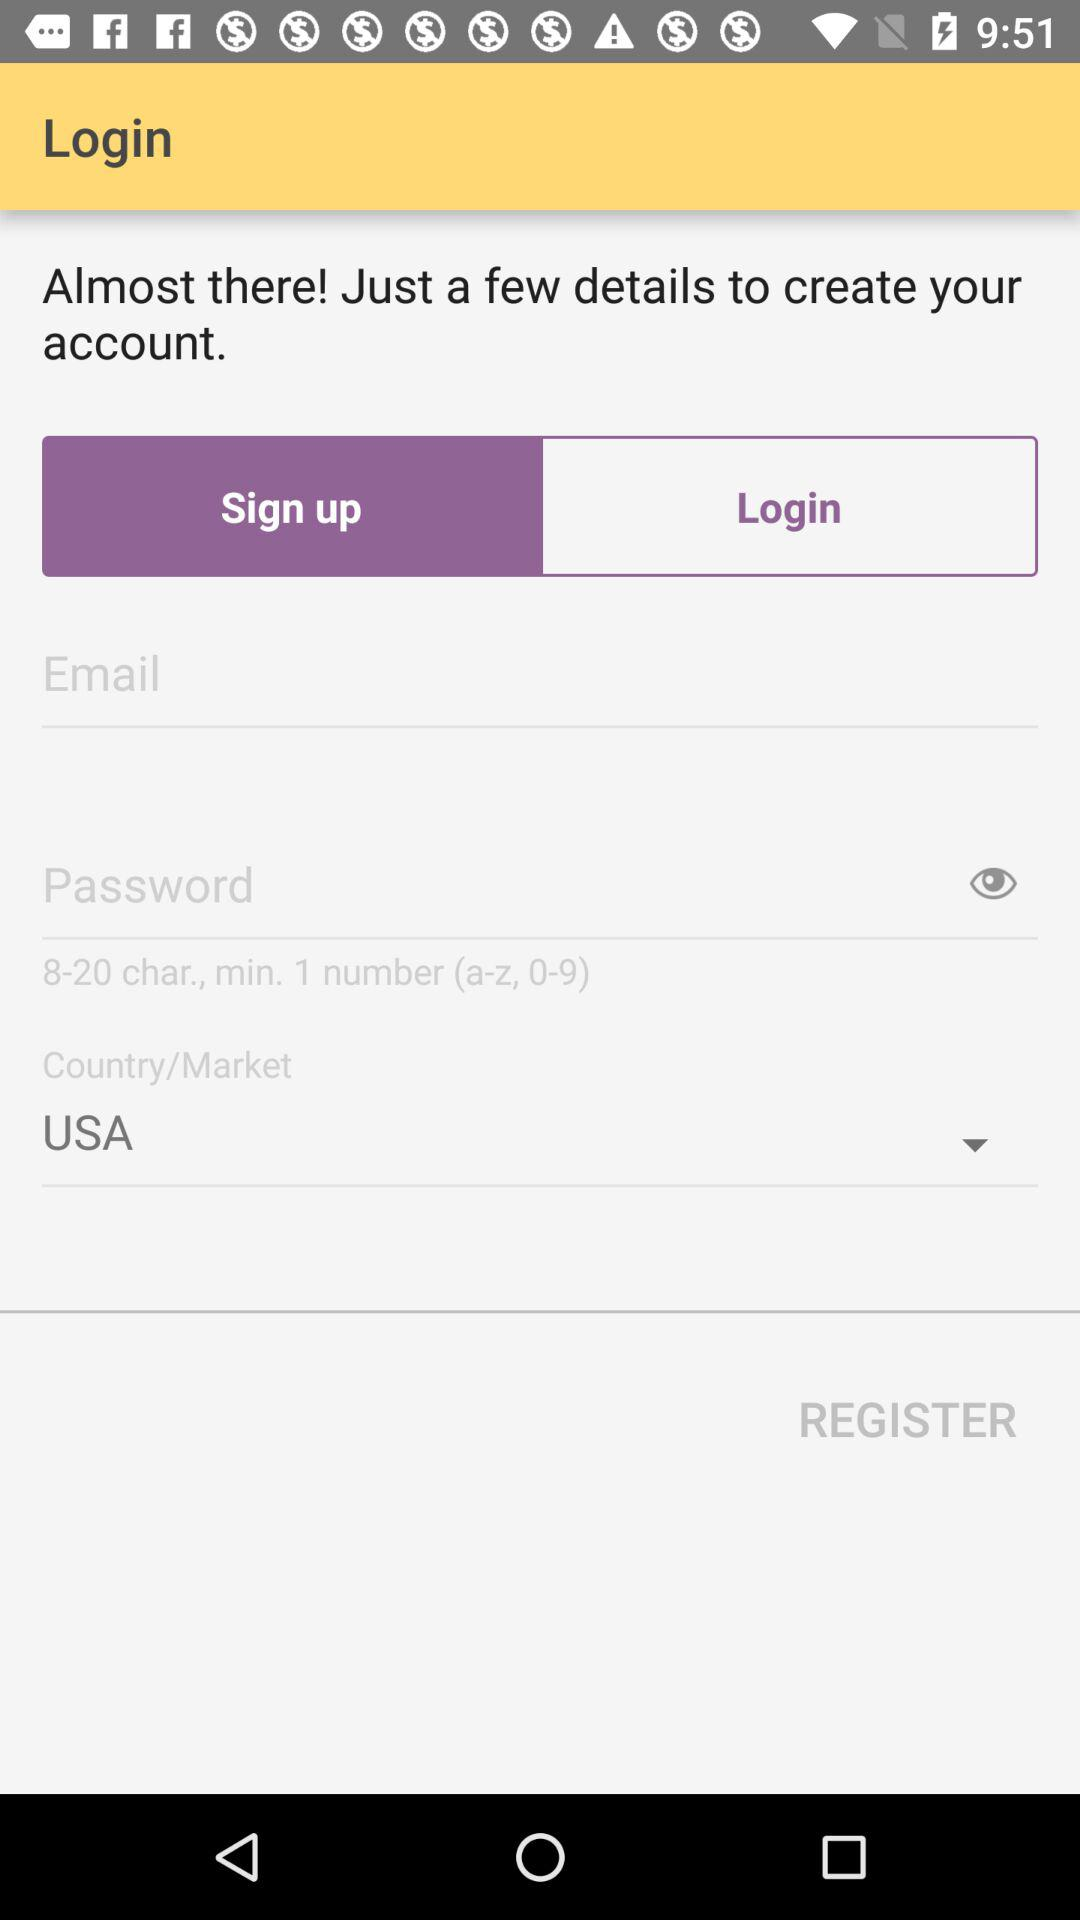How many minimum characters can we use for a password? You can use a minimum of 8 characters. 